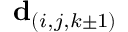Convert formula to latex. <formula><loc_0><loc_0><loc_500><loc_500>d _ { ( i , j , k \pm 1 ) }</formula> 